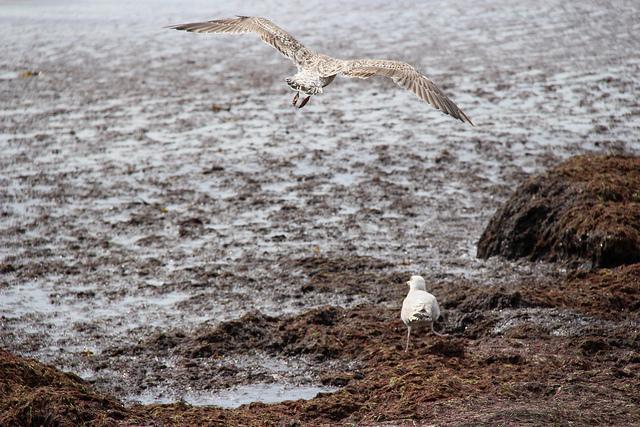How many teddy bears are there?
Give a very brief answer. 0. 